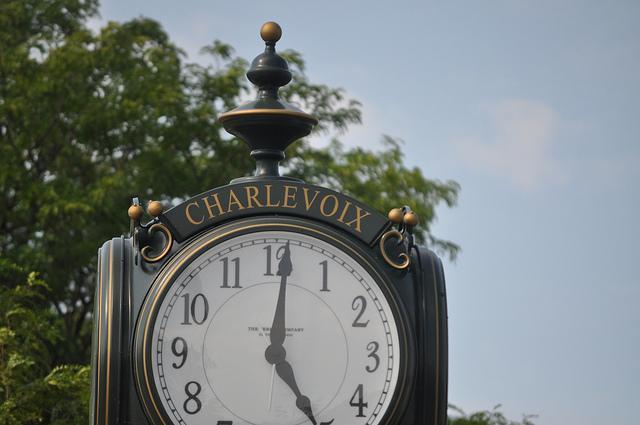How many depictions of a dog can be seen?
Give a very brief answer. 0. 